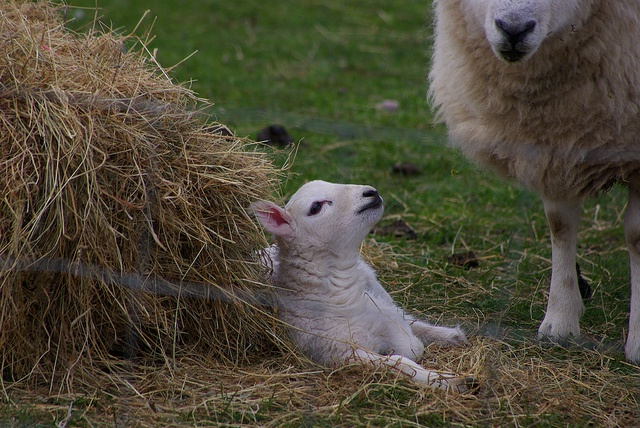Describe the objects in this image and their specific colors. I can see sheep in olive, gray, and black tones and sheep in olive, gray, and black tones in this image. 